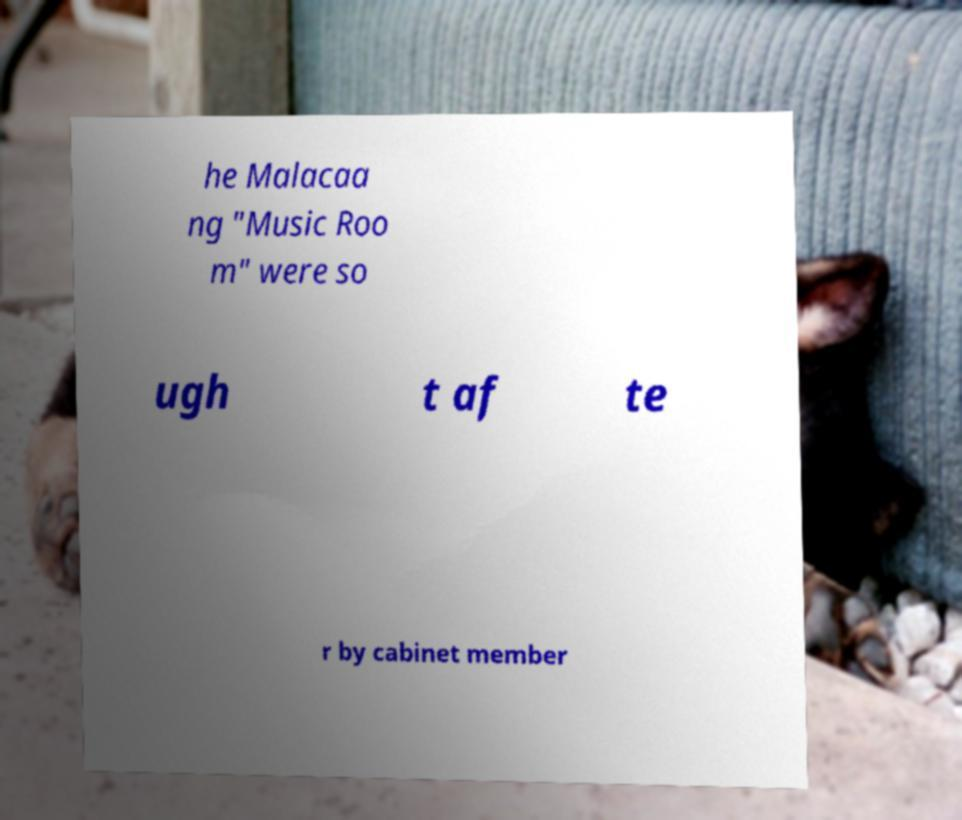Could you extract and type out the text from this image? he Malacaa ng "Music Roo m" were so ugh t af te r by cabinet member 